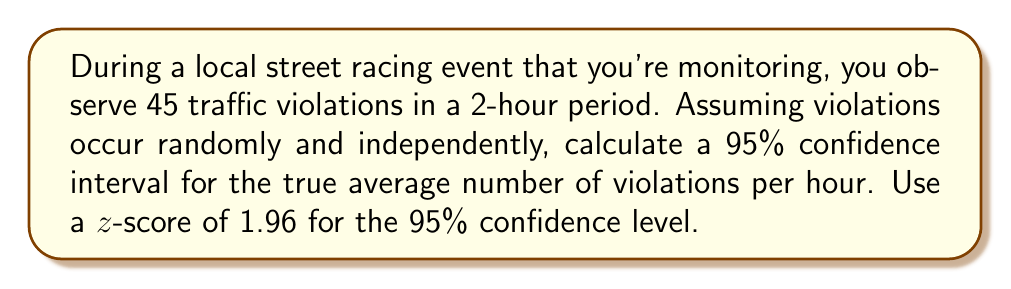Provide a solution to this math problem. Let's approach this step-by-step:

1) First, we need to calculate the sample mean ($\bar{x}$) per hour:
   $$\bar{x} = \frac{45 \text{ violations}}{2 \text{ hours}} = 22.5 \text{ violations/hour}$$

2) For a Poisson distribution, which is appropriate for count data like this, the variance is equal to the mean. So, the standard error (SE) is:
   $$SE = \sqrt{\frac{\bar{x}}{n}} = \sqrt{\frac{22.5}{2}} = 3.354$$

3) The formula for a confidence interval is:
   $$\text{CI} = \bar{x} \pm z \cdot SE$$

   Where $z$ is the z-score for the desired confidence level (1.96 for 95% CI)

4) Plugging in our values:
   $$\text{CI} = 22.5 \pm 1.96 \cdot 3.354$$

5) Calculate the margin of error:
   $$1.96 \cdot 3.354 = 6.574$$

6) Therefore, the confidence interval is:
   $$22.5 - 6.574 \text{ to } 22.5 + 6.574$$
   $$15.926 \text{ to } 29.074$$

So, we can be 95% confident that the true average number of violations per hour falls between 15.926 and 29.074.
Answer: (15.926, 29.074) violations per hour 